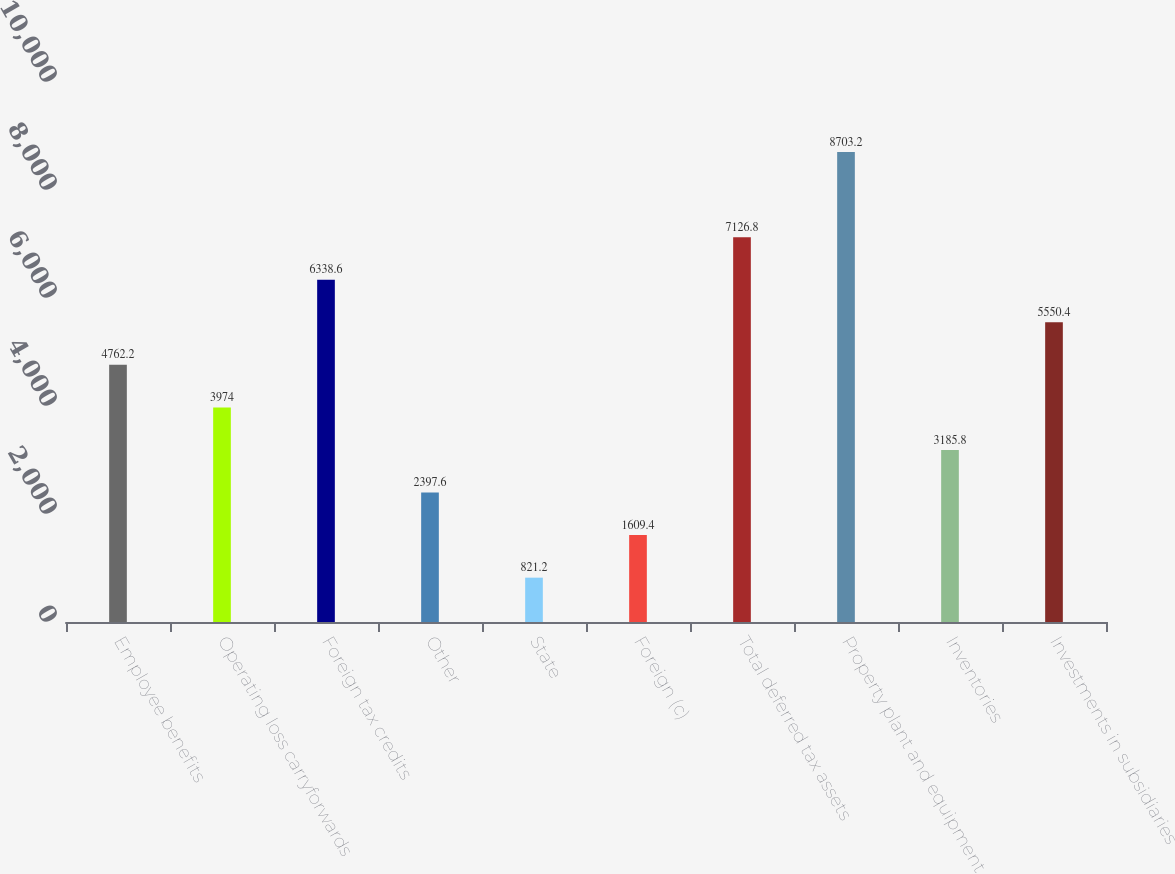Convert chart. <chart><loc_0><loc_0><loc_500><loc_500><bar_chart><fcel>Employee benefits<fcel>Operating loss carryforwards<fcel>Foreign tax credits<fcel>Other<fcel>State<fcel>Foreign (c)<fcel>Total deferred tax assets<fcel>Property plant and equipment<fcel>Inventories<fcel>Investments in subsidiaries<nl><fcel>4762.2<fcel>3974<fcel>6338.6<fcel>2397.6<fcel>821.2<fcel>1609.4<fcel>7126.8<fcel>8703.2<fcel>3185.8<fcel>5550.4<nl></chart> 